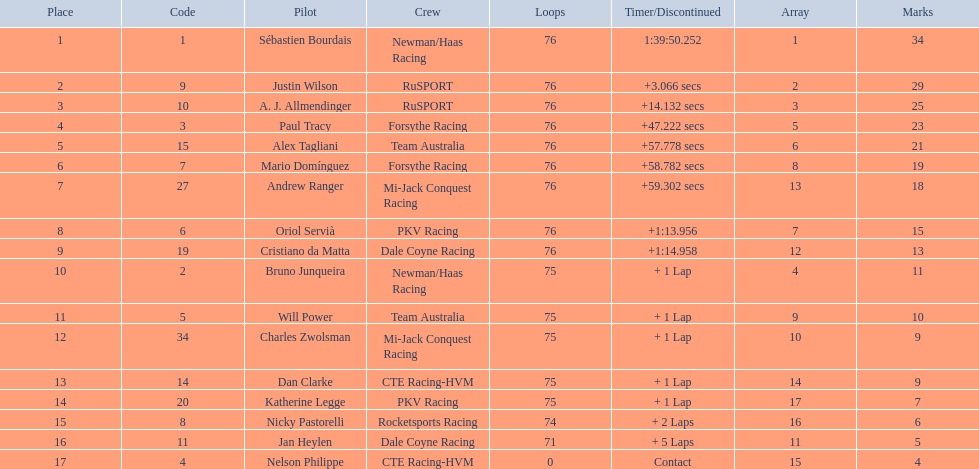Is there a driver named charles zwolsman? Charles Zwolsman. How many points did he acquire? 9. Were there any other entries that got the same number of points? 9. Give me the full table as a dictionary. {'header': ['Place', 'Code', 'Pilot', 'Crew', 'Loops', 'Timer/Discontinued', 'Array', 'Marks'], 'rows': [['1', '1', 'Sébastien Bourdais', 'Newman/Haas Racing', '76', '1:39:50.252', '1', '34'], ['2', '9', 'Justin Wilson', 'RuSPORT', '76', '+3.066 secs', '2', '29'], ['3', '10', 'A. J. Allmendinger', 'RuSPORT', '76', '+14.132 secs', '3', '25'], ['4', '3', 'Paul Tracy', 'Forsythe Racing', '76', '+47.222 secs', '5', '23'], ['5', '15', 'Alex Tagliani', 'Team Australia', '76', '+57.778 secs', '6', '21'], ['6', '7', 'Mario Domínguez', 'Forsythe Racing', '76', '+58.782 secs', '8', '19'], ['7', '27', 'Andrew Ranger', 'Mi-Jack Conquest Racing', '76', '+59.302 secs', '13', '18'], ['8', '6', 'Oriol Servià', 'PKV Racing', '76', '+1:13.956', '7', '15'], ['9', '19', 'Cristiano da Matta', 'Dale Coyne Racing', '76', '+1:14.958', '12', '13'], ['10', '2', 'Bruno Junqueira', 'Newman/Haas Racing', '75', '+ 1 Lap', '4', '11'], ['11', '5', 'Will Power', 'Team Australia', '75', '+ 1 Lap', '9', '10'], ['12', '34', 'Charles Zwolsman', 'Mi-Jack Conquest Racing', '75', '+ 1 Lap', '10', '9'], ['13', '14', 'Dan Clarke', 'CTE Racing-HVM', '75', '+ 1 Lap', '14', '9'], ['14', '20', 'Katherine Legge', 'PKV Racing', '75', '+ 1 Lap', '17', '7'], ['15', '8', 'Nicky Pastorelli', 'Rocketsports Racing', '74', '+ 2 Laps', '16', '6'], ['16', '11', 'Jan Heylen', 'Dale Coyne Racing', '71', '+ 5 Laps', '11', '5'], ['17', '4', 'Nelson Philippe', 'CTE Racing-HVM', '0', 'Contact', '15', '4']]} Who did that entry belong to? Dan Clarke. 